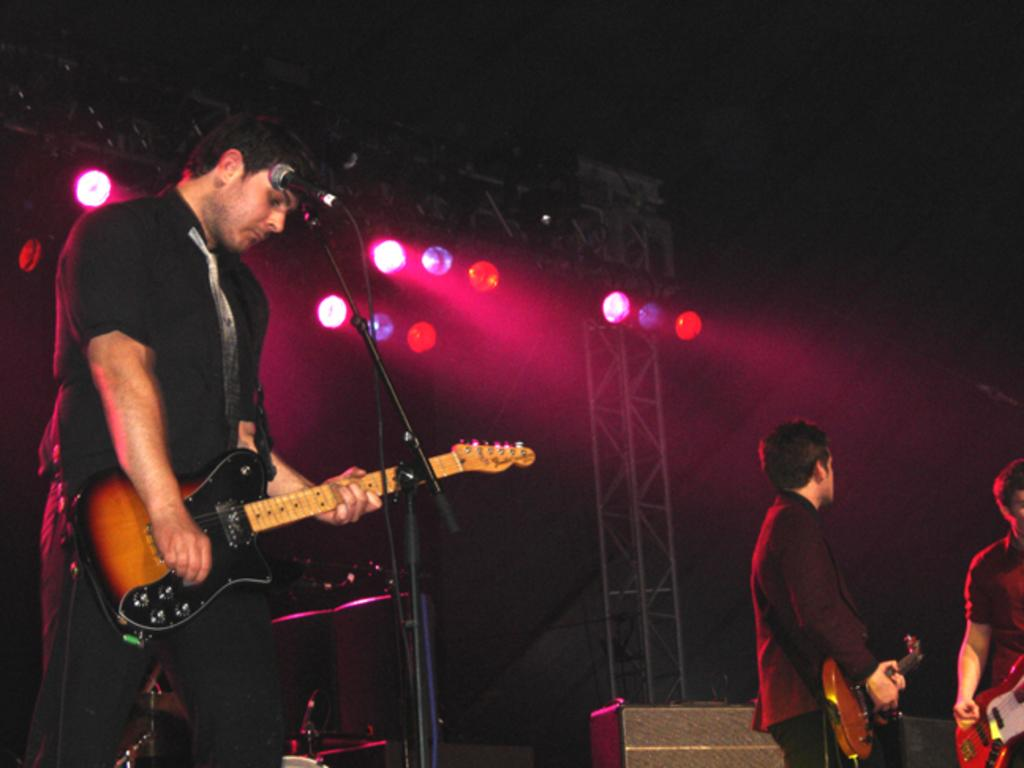What is the man in the image doing? The man in the image is playing a guitar. What is in front of the man playing the guitar? There is a microphone in front of the man playing the guitar. Can you describe the people in the background of the image? There are two other men standing in the background. What can be seen in the image that provides illumination? There are lights visible in the image. What type of church can be seen in the background of the image? There is no church visible in the background of the image. What are the two men in the background learning in the image? The image does not provide information about what the two men in the background might be learning. 